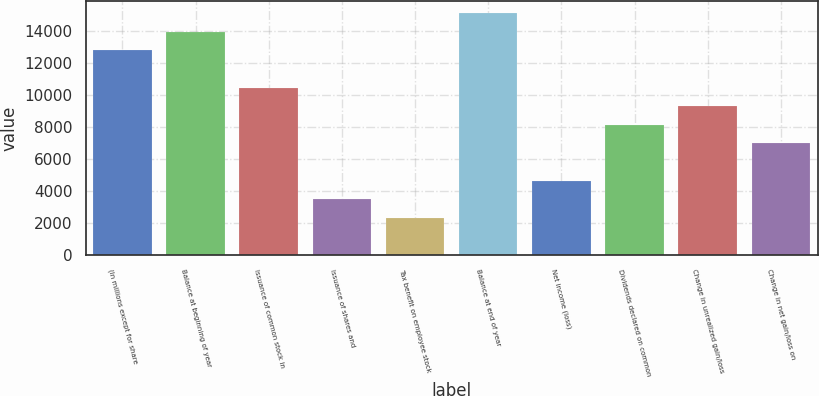<chart> <loc_0><loc_0><loc_500><loc_500><bar_chart><fcel>(In millions except for share<fcel>Balance at beginning of year<fcel>Issuance of common stock in<fcel>Issuance of shares and<fcel>Tax benefit on employee stock<fcel>Balance at end of year<fcel>Net income (loss)<fcel>Dividends declared on common<fcel>Change in unrealized gain/loss<fcel>Change in net gain/loss on<nl><fcel>12802.3<fcel>13965.6<fcel>10475.7<fcel>3495.9<fcel>2332.6<fcel>15128.9<fcel>4659.2<fcel>8149.1<fcel>9312.4<fcel>6985.8<nl></chart> 